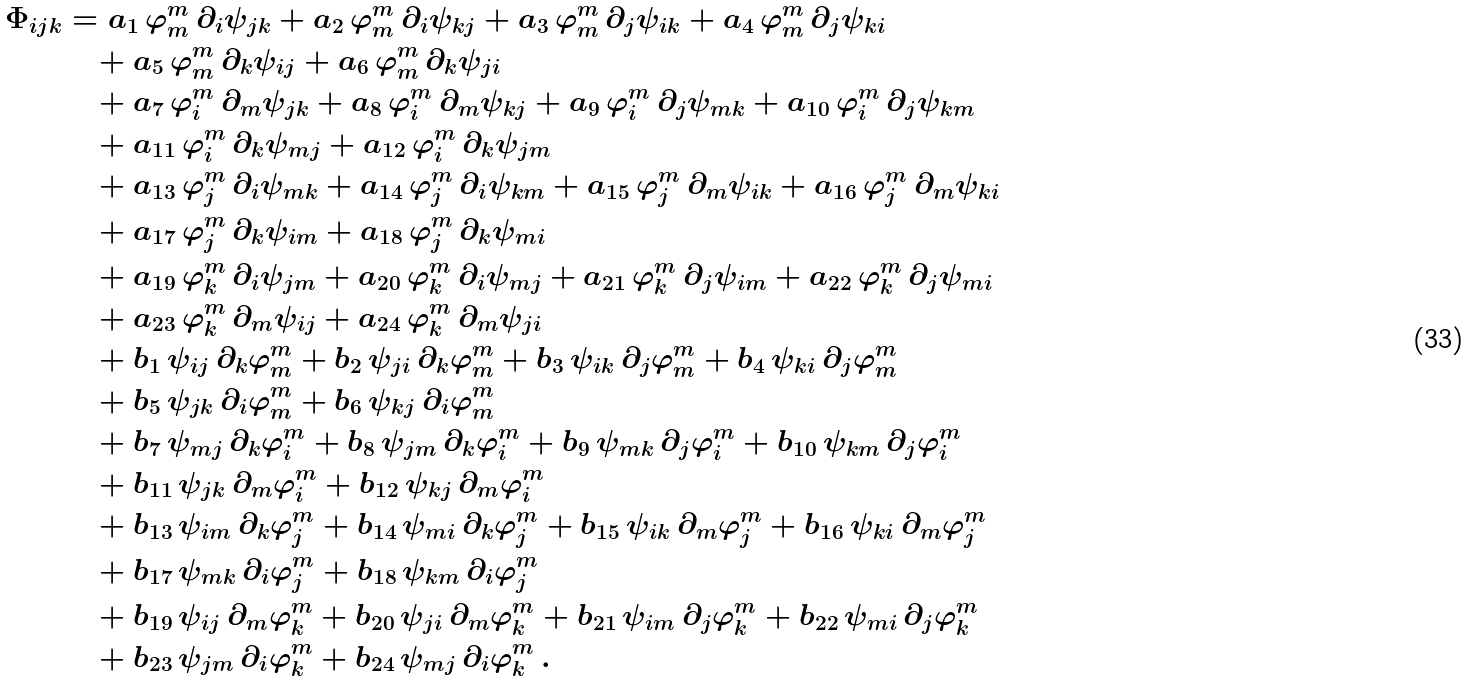<formula> <loc_0><loc_0><loc_500><loc_500>\Phi _ { i j k } & = a _ { 1 } \, \varphi ^ { m } _ { m } \, \partial _ { i } \psi _ { j k } + a _ { 2 } \, \varphi ^ { m } _ { m } \, \partial _ { i } \psi _ { k j } + a _ { 3 } \, \varphi ^ { m } _ { m } \, \partial _ { j } \psi _ { i k } + a _ { 4 } \, \varphi ^ { m } _ { m } \, \partial _ { j } \psi _ { k i } \\ & \quad + a _ { 5 } \, \varphi ^ { m } _ { m } \, \partial _ { k } \psi _ { i j } + a _ { 6 } \, \varphi ^ { m } _ { m } \, \partial _ { k } \psi _ { j i } \\ & \quad + a _ { 7 } \, \varphi ^ { m } _ { i } \, \partial _ { m } \psi _ { j k } + a _ { 8 } \, \varphi ^ { m } _ { i } \, \partial _ { m } \psi _ { k j } + a _ { 9 } \, \varphi ^ { m } _ { i } \, \partial _ { j } \psi _ { m k } + a _ { 1 0 } \, \varphi ^ { m } _ { i } \, \partial _ { j } \psi _ { k m } \\ & \quad + a _ { 1 1 } \, \varphi ^ { m } _ { i } \, \partial _ { k } \psi _ { m j } + a _ { 1 2 } \, \varphi ^ { m } _ { i } \, \partial _ { k } \psi _ { j m } \\ & \quad + a _ { 1 3 } \, \varphi ^ { m } _ { j } \, \partial _ { i } \psi _ { m k } + a _ { 1 4 } \, \varphi ^ { m } _ { j } \, \partial _ { i } \psi _ { k m } + a _ { 1 5 } \, \varphi ^ { m } _ { j } \, \partial _ { m } \psi _ { i k } + a _ { 1 6 } \, \varphi ^ { m } _ { j } \, \partial _ { m } \psi _ { k i } \\ & \quad + a _ { 1 7 } \, \varphi ^ { m } _ { j } \, \partial _ { k } \psi _ { i m } + a _ { 1 8 } \, \varphi ^ { m } _ { j } \, \partial _ { k } \psi _ { m i } \\ & \quad + a _ { 1 9 } \, \varphi ^ { m } _ { k } \, \partial _ { i } \psi _ { j m } + a _ { 2 0 } \, \varphi ^ { m } _ { k } \, \partial _ { i } \psi _ { m j } + a _ { 2 1 } \, \varphi ^ { m } _ { k } \, \partial _ { j } \psi _ { i m } + a _ { 2 2 } \, \varphi ^ { m } _ { k } \, \partial _ { j } \psi _ { m i } \\ & \quad + a _ { 2 3 } \, \varphi ^ { m } _ { k } \, \partial _ { m } \psi _ { i j } + a _ { 2 4 } \, \varphi ^ { m } _ { k } \, \partial _ { m } \psi _ { j i } \\ & \quad + b _ { 1 } \, \psi _ { i j } \, \partial _ { k } \varphi ^ { m } _ { m } + b _ { 2 } \, \psi _ { j i } \, \partial _ { k } \varphi ^ { m } _ { m } + b _ { 3 } \, \psi _ { i k } \, \partial _ { j } \varphi ^ { m } _ { m } + b _ { 4 } \, \psi _ { k i } \, \partial _ { j } \varphi ^ { m } _ { m } \\ & \quad + b _ { 5 } \, \psi _ { j k } \, \partial _ { i } \varphi ^ { m } _ { m } + b _ { 6 } \, \psi _ { k j } \, \partial _ { i } \varphi ^ { m } _ { m } \\ & \quad + b _ { 7 } \, \psi _ { m j } \, \partial _ { k } \varphi ^ { m } _ { i } + b _ { 8 } \, \psi _ { j m } \, \partial _ { k } \varphi ^ { m } _ { i } + b _ { 9 } \, \psi _ { m k } \, \partial _ { j } \varphi ^ { m } _ { i } + b _ { 1 0 } \, \psi _ { k m } \, \partial _ { j } \varphi ^ { m } _ { i } \\ & \quad + b _ { 1 1 } \, \psi _ { j k } \, \partial _ { m } \varphi ^ { m } _ { i } + b _ { 1 2 } \, \psi _ { k j } \, \partial _ { m } \varphi ^ { m } _ { i } \\ & \quad + b _ { 1 3 } \, \psi _ { i m } \, \partial _ { k } \varphi ^ { m } _ { j } + b _ { 1 4 } \, \psi _ { m i } \, \partial _ { k } \varphi ^ { m } _ { j } + b _ { 1 5 } \, \psi _ { i k } \, \partial _ { m } \varphi ^ { m } _ { j } + b _ { 1 6 } \, \psi _ { k i } \, \partial _ { m } \varphi ^ { m } _ { j } \\ & \quad + b _ { 1 7 } \, \psi _ { m k } \, \partial _ { i } \varphi ^ { m } _ { j } + b _ { 1 8 } \, \psi _ { k m } \, \partial _ { i } \varphi ^ { m } _ { j } \\ & \quad + b _ { 1 9 } \, \psi _ { i j } \, \partial _ { m } \varphi ^ { m } _ { k } + b _ { 2 0 } \, \psi _ { j i } \, \partial _ { m } \varphi ^ { m } _ { k } + b _ { 2 1 } \, \psi _ { i m } \, \partial _ { j } \varphi ^ { m } _ { k } + b _ { 2 2 } \, \psi _ { m i } \, \partial _ { j } \varphi ^ { m } _ { k } \\ & \quad + b _ { 2 3 } \, \psi _ { j m } \, \partial _ { i } \varphi ^ { m } _ { k } + b _ { 2 4 } \, \psi _ { m j } \, \partial _ { i } \varphi ^ { m } _ { k } \, .</formula> 